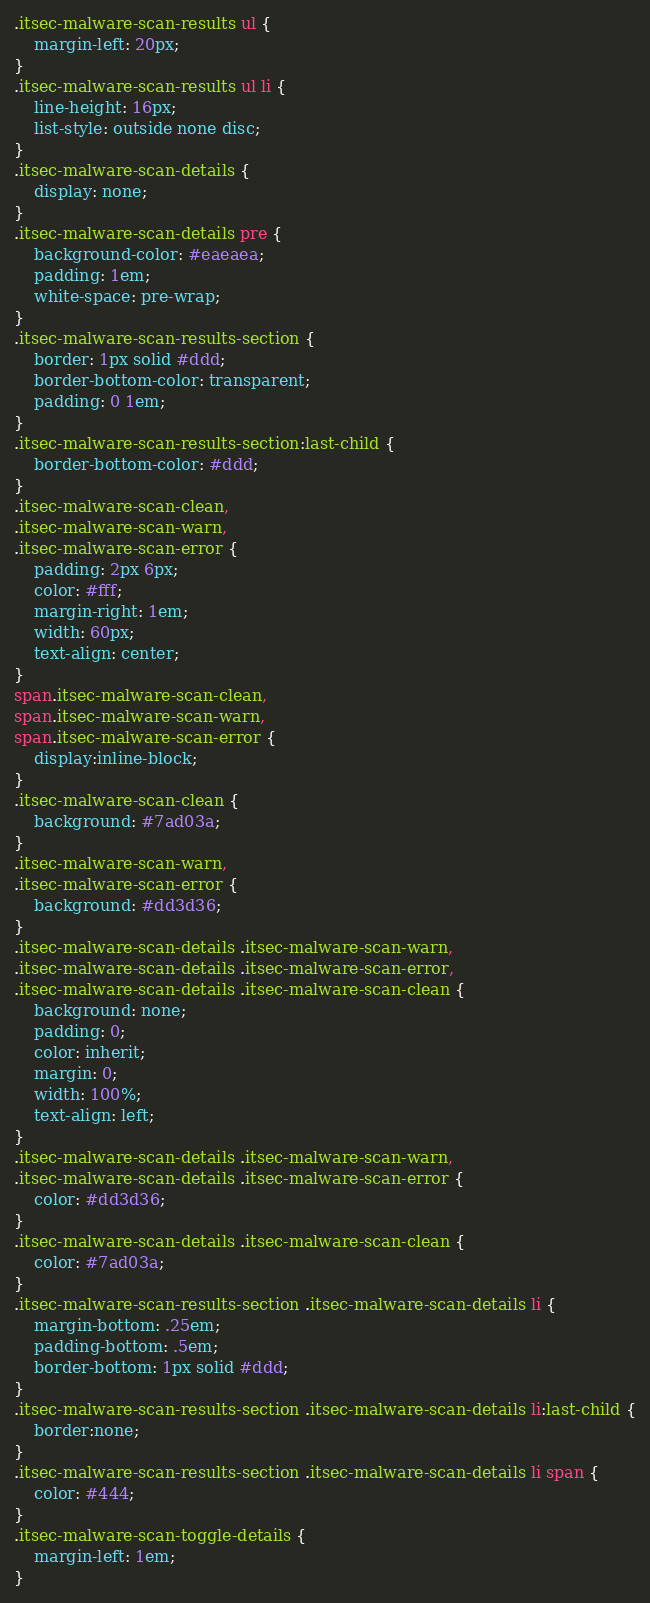Convert code to text. <code><loc_0><loc_0><loc_500><loc_500><_CSS_>.itsec-malware-scan-results ul {
	margin-left: 20px;
}
.itsec-malware-scan-results ul li {
	line-height: 16px;
	list-style: outside none disc;
}
.itsec-malware-scan-details {
	display: none;
}
.itsec-malware-scan-details pre {
	background-color: #eaeaea;
	padding: 1em;
	white-space: pre-wrap;
}
.itsec-malware-scan-results-section {
	border: 1px solid #ddd;
	border-bottom-color: transparent;
	padding: 0 1em;
}
.itsec-malware-scan-results-section:last-child {
	border-bottom-color: #ddd;
}
.itsec-malware-scan-clean,
.itsec-malware-scan-warn,
.itsec-malware-scan-error {
	padding: 2px 6px;
	color: #fff;
	margin-right: 1em;
	width: 60px;
	text-align: center;
}
span.itsec-malware-scan-clean,
span.itsec-malware-scan-warn,
span.itsec-malware-scan-error {
	display:inline-block;
}
.itsec-malware-scan-clean {
	background: #7ad03a;
}
.itsec-malware-scan-warn,
.itsec-malware-scan-error {
	background: #dd3d36;
}
.itsec-malware-scan-details .itsec-malware-scan-warn,
.itsec-malware-scan-details .itsec-malware-scan-error,
.itsec-malware-scan-details .itsec-malware-scan-clean {
	background: none;
	padding: 0;
	color: inherit;
	margin: 0;
	width: 100%;
	text-align: left;
}
.itsec-malware-scan-details .itsec-malware-scan-warn,
.itsec-malware-scan-details .itsec-malware-scan-error {
	color: #dd3d36;
}
.itsec-malware-scan-details .itsec-malware-scan-clean {
	color: #7ad03a;
}
.itsec-malware-scan-results-section .itsec-malware-scan-details li {
	margin-bottom: .25em;
	padding-bottom: .5em;
	border-bottom: 1px solid #ddd;
}
.itsec-malware-scan-results-section .itsec-malware-scan-details li:last-child {
	border:none;
}
.itsec-malware-scan-results-section .itsec-malware-scan-details li span {
	color: #444;
}
.itsec-malware-scan-toggle-details {
	margin-left: 1em;
}
</code> 